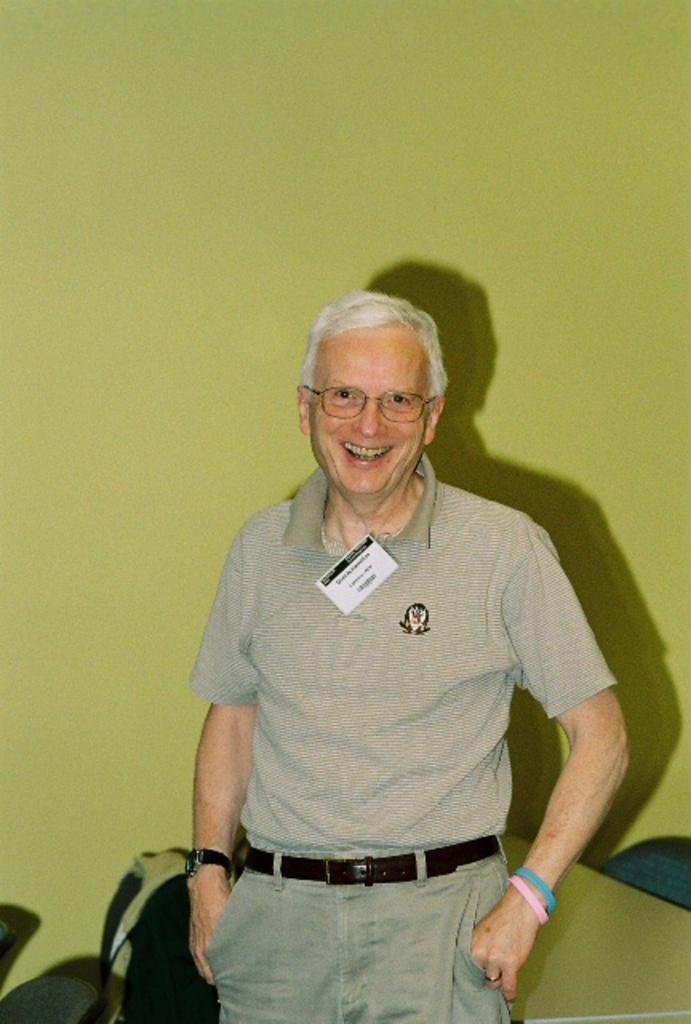What color is the wall in the image? The wall in the image is green. What can be seen on the wall in the image? The provided facts do not mention anything on the wall. Is there a person in the image? Yes, there is a man standing in the image. What is the man doing in the image? The provided facts do not mention what the man is doing. What type of gate is visible in the image? There is no gate present in the image. How low is the fireman's ladder in the image? There is no fireman or ladder present in the image. 